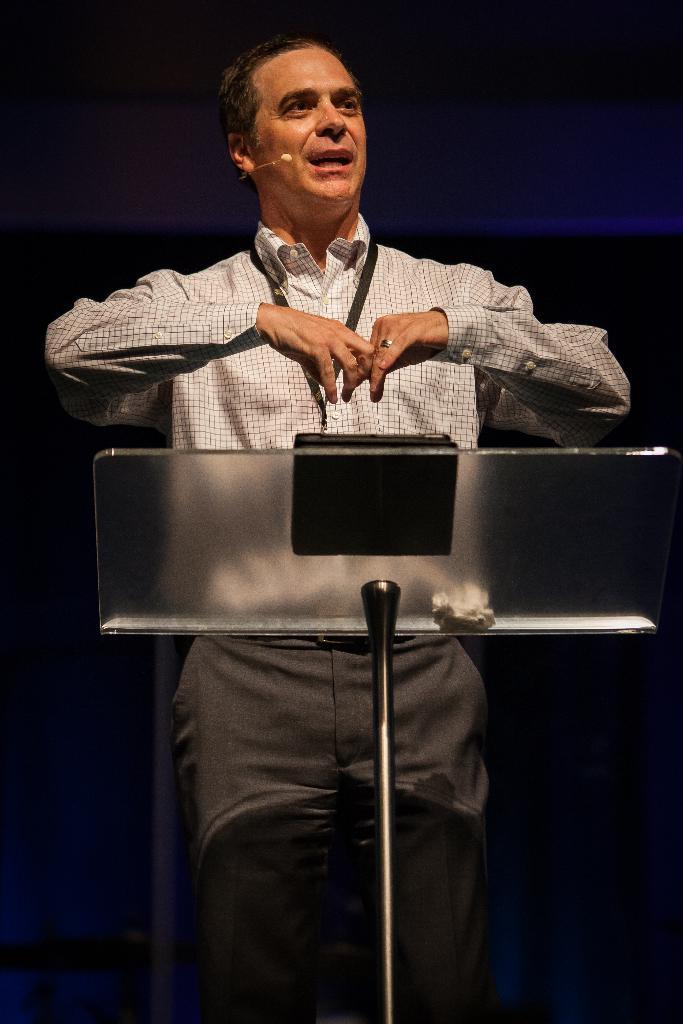Can you describe this image briefly? In the picture we can see a man wearing white color checks shirt, also wearing ID card, standing behind glass podium and in the background of the picture there is dark view. 